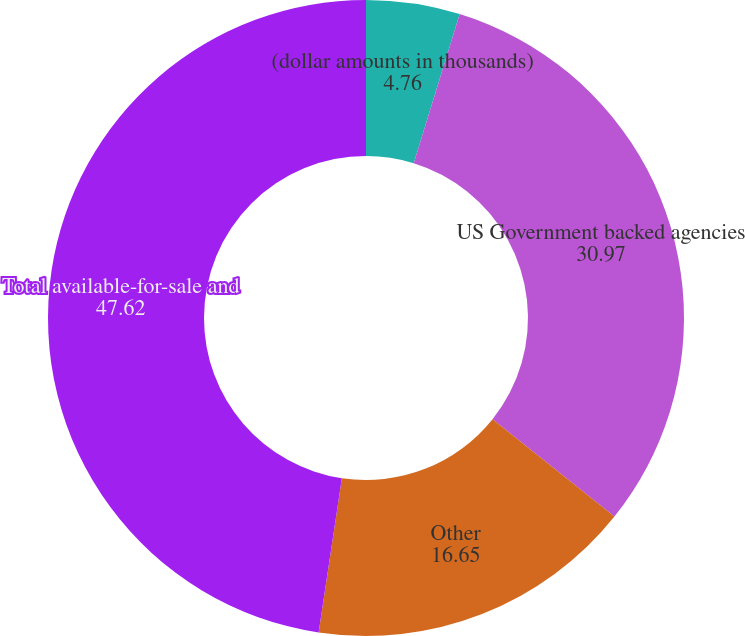<chart> <loc_0><loc_0><loc_500><loc_500><pie_chart><fcel>(dollar amounts in thousands)<fcel>US Government backed agencies<fcel>Other<fcel>Total available-for-sale and<fcel>Duration in years (1)<nl><fcel>4.76%<fcel>30.97%<fcel>16.65%<fcel>47.62%<fcel>0.0%<nl></chart> 